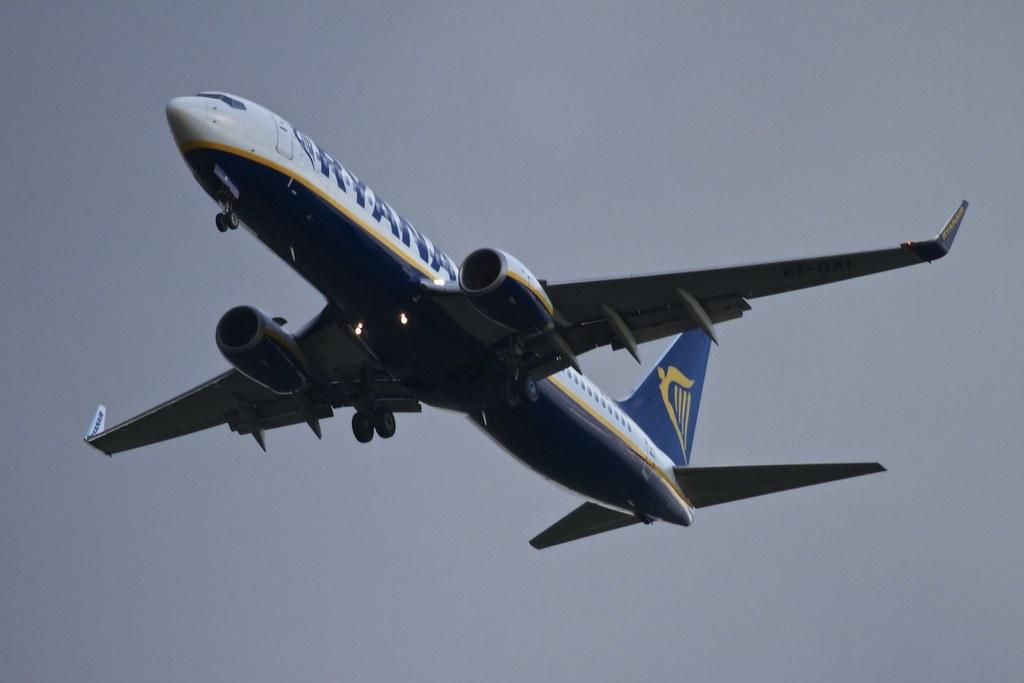What is the main subject of the image? The main subject of the image is an airplane. What colors are used to paint the airplane? The airplane is in white and blue color. What can be seen in the background of the image? The sky is visible in the background of the image. What type of stage can be seen in the image? There is no stage present in the image; it features an airplane in the sky. What currency exchange rate is mentioned in the image? There is no mention of currency exchange rates in the image; it only shows an airplane and the sky. 